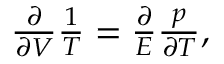<formula> <loc_0><loc_0><loc_500><loc_500>\begin{array} { r } { \frac { \partial } { \partial V } \frac { 1 } { T } = \frac { \partial } { E } \frac { p } { \partial T } , } \end{array}</formula> 